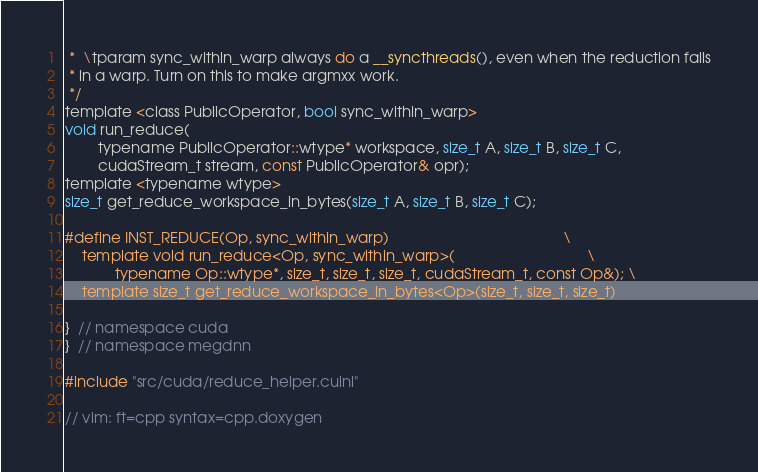Convert code to text. <code><loc_0><loc_0><loc_500><loc_500><_Cuda_> *  \tparam sync_within_warp always do a __syncthreads(), even when the reduction falls
 * in a warp. Turn on this to make argmxx work.
 */
template <class PublicOperator, bool sync_within_warp>
void run_reduce(
        typename PublicOperator::wtype* workspace, size_t A, size_t B, size_t C,
        cudaStream_t stream, const PublicOperator& opr);
template <typename wtype>
size_t get_reduce_workspace_in_bytes(size_t A, size_t B, size_t C);

#define INST_REDUCE(Op, sync_within_warp)                                          \
    template void run_reduce<Op, sync_within_warp>(                                \
            typename Op::wtype*, size_t, size_t, size_t, cudaStream_t, const Op&); \
    template size_t get_reduce_workspace_in_bytes<Op>(size_t, size_t, size_t)

}  // namespace cuda
}  // namespace megdnn

#include "src/cuda/reduce_helper.cuinl"

// vim: ft=cpp syntax=cpp.doxygen
</code> 